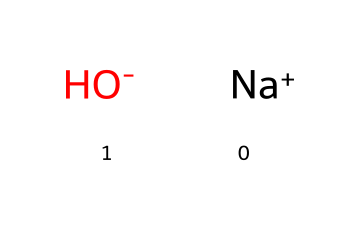What is the name of this chemical? The chemical represented by the SMILES notation is sodium hydroxide, which is indicated by the presence of sodium (Na) and hydroxide (OH).
Answer: sodium hydroxide How many atoms are present in this chemical structure? The chemical consists of two distinct parts: one sodium atom (Na) and one hydroxide ion (OH), resulting in a total of two atoms.
Answer: two Is sodium hydroxide an acid or a base? Sodium hydroxide contains a hydroxide ion, which is characteristic of bases. Therefore, it is classified as a strong base.
Answer: base What charge does the hydroxide ion carry? The hydroxide ion (OH-) has a negative charge, as indicated by the minus sign in the chemical notation.
Answer: negative What is one common use of sodium hydroxide? Sodium hydroxide is widely used in cleaning products, including those for cleaning stadium seats, due to its strong cleaning properties.
Answer: cleaning What is the pH of a sodium hydroxide solution? Sodium hydroxide is a strong base; consequently, its aqueous solution has a high pH, typically above 12.
Answer: above 12 What does the presence of Na+ indicate about sodium hydroxide? The presence of Na+ denotes that sodium hydroxide is a salt formed from a strong base (NaOH), indicating its solubility in water.
Answer: salt 